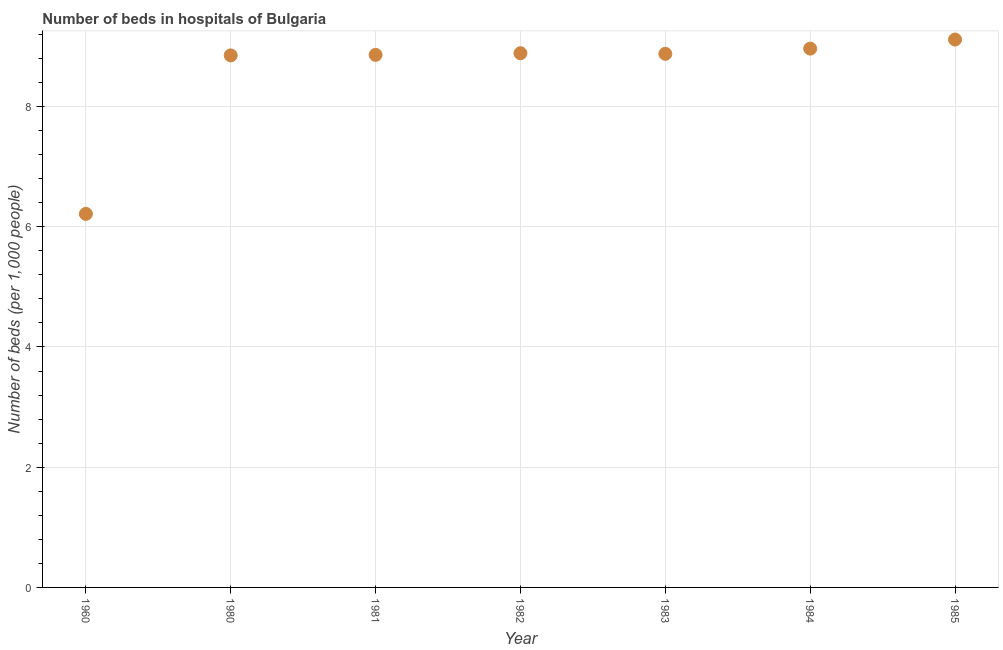What is the number of hospital beds in 1982?
Offer a terse response. 8.89. Across all years, what is the maximum number of hospital beds?
Give a very brief answer. 9.11. Across all years, what is the minimum number of hospital beds?
Offer a terse response. 6.21. What is the sum of the number of hospital beds?
Provide a short and direct response. 59.76. What is the difference between the number of hospital beds in 1983 and 1985?
Your answer should be compact. -0.24. What is the average number of hospital beds per year?
Your answer should be compact. 8.54. What is the median number of hospital beds?
Keep it short and to the point. 8.88. Do a majority of the years between 1984 and 1981 (inclusive) have number of hospital beds greater than 6 %?
Provide a short and direct response. Yes. What is the ratio of the number of hospital beds in 1982 to that in 1985?
Ensure brevity in your answer.  0.98. Is the number of hospital beds in 1960 less than that in 1983?
Your response must be concise. Yes. What is the difference between the highest and the second highest number of hospital beds?
Provide a succinct answer. 0.15. What is the difference between the highest and the lowest number of hospital beds?
Ensure brevity in your answer.  2.9. In how many years, is the number of hospital beds greater than the average number of hospital beds taken over all years?
Your answer should be very brief. 6. Does the number of hospital beds monotonically increase over the years?
Provide a succinct answer. No. How many dotlines are there?
Offer a terse response. 1. How many years are there in the graph?
Your answer should be compact. 7. Does the graph contain any zero values?
Provide a short and direct response. No. Does the graph contain grids?
Keep it short and to the point. Yes. What is the title of the graph?
Provide a short and direct response. Number of beds in hospitals of Bulgaria. What is the label or title of the Y-axis?
Offer a terse response. Number of beds (per 1,0 people). What is the Number of beds (per 1,000 people) in 1960?
Your answer should be compact. 6.21. What is the Number of beds (per 1,000 people) in 1980?
Provide a short and direct response. 8.85. What is the Number of beds (per 1,000 people) in 1981?
Offer a very short reply. 8.86. What is the Number of beds (per 1,000 people) in 1982?
Give a very brief answer. 8.89. What is the Number of beds (per 1,000 people) in 1983?
Make the answer very short. 8.88. What is the Number of beds (per 1,000 people) in 1984?
Provide a short and direct response. 8.96. What is the Number of beds (per 1,000 people) in 1985?
Provide a succinct answer. 9.11. What is the difference between the Number of beds (per 1,000 people) in 1960 and 1980?
Your answer should be compact. -2.64. What is the difference between the Number of beds (per 1,000 people) in 1960 and 1981?
Keep it short and to the point. -2.65. What is the difference between the Number of beds (per 1,000 people) in 1960 and 1982?
Make the answer very short. -2.67. What is the difference between the Number of beds (per 1,000 people) in 1960 and 1983?
Your answer should be compact. -2.66. What is the difference between the Number of beds (per 1,000 people) in 1960 and 1984?
Your answer should be compact. -2.75. What is the difference between the Number of beds (per 1,000 people) in 1960 and 1985?
Offer a terse response. -2.9. What is the difference between the Number of beds (per 1,000 people) in 1980 and 1981?
Keep it short and to the point. -0.01. What is the difference between the Number of beds (per 1,000 people) in 1980 and 1982?
Your answer should be very brief. -0.04. What is the difference between the Number of beds (per 1,000 people) in 1980 and 1983?
Give a very brief answer. -0.03. What is the difference between the Number of beds (per 1,000 people) in 1980 and 1984?
Provide a short and direct response. -0.11. What is the difference between the Number of beds (per 1,000 people) in 1980 and 1985?
Your response must be concise. -0.26. What is the difference between the Number of beds (per 1,000 people) in 1981 and 1982?
Your answer should be very brief. -0.03. What is the difference between the Number of beds (per 1,000 people) in 1981 and 1983?
Provide a succinct answer. -0.02. What is the difference between the Number of beds (per 1,000 people) in 1981 and 1984?
Give a very brief answer. -0.1. What is the difference between the Number of beds (per 1,000 people) in 1981 and 1985?
Your answer should be very brief. -0.26. What is the difference between the Number of beds (per 1,000 people) in 1982 and 1983?
Your answer should be very brief. 0.01. What is the difference between the Number of beds (per 1,000 people) in 1982 and 1984?
Give a very brief answer. -0.08. What is the difference between the Number of beds (per 1,000 people) in 1982 and 1985?
Keep it short and to the point. -0.23. What is the difference between the Number of beds (per 1,000 people) in 1983 and 1984?
Ensure brevity in your answer.  -0.09. What is the difference between the Number of beds (per 1,000 people) in 1983 and 1985?
Provide a succinct answer. -0.24. What is the difference between the Number of beds (per 1,000 people) in 1984 and 1985?
Offer a very short reply. -0.15. What is the ratio of the Number of beds (per 1,000 people) in 1960 to that in 1980?
Ensure brevity in your answer.  0.7. What is the ratio of the Number of beds (per 1,000 people) in 1960 to that in 1981?
Offer a terse response. 0.7. What is the ratio of the Number of beds (per 1,000 people) in 1960 to that in 1982?
Provide a short and direct response. 0.7. What is the ratio of the Number of beds (per 1,000 people) in 1960 to that in 1983?
Make the answer very short. 0.7. What is the ratio of the Number of beds (per 1,000 people) in 1960 to that in 1984?
Offer a very short reply. 0.69. What is the ratio of the Number of beds (per 1,000 people) in 1960 to that in 1985?
Provide a succinct answer. 0.68. What is the ratio of the Number of beds (per 1,000 people) in 1980 to that in 1981?
Your answer should be very brief. 1. What is the ratio of the Number of beds (per 1,000 people) in 1980 to that in 1982?
Provide a succinct answer. 1. What is the ratio of the Number of beds (per 1,000 people) in 1980 to that in 1983?
Your answer should be compact. 1. What is the ratio of the Number of beds (per 1,000 people) in 1980 to that in 1984?
Make the answer very short. 0.99. What is the ratio of the Number of beds (per 1,000 people) in 1980 to that in 1985?
Your response must be concise. 0.97. What is the ratio of the Number of beds (per 1,000 people) in 1981 to that in 1982?
Make the answer very short. 1. What is the ratio of the Number of beds (per 1,000 people) in 1981 to that in 1983?
Provide a succinct answer. 1. What is the ratio of the Number of beds (per 1,000 people) in 1981 to that in 1985?
Your answer should be very brief. 0.97. What is the ratio of the Number of beds (per 1,000 people) in 1982 to that in 1983?
Your answer should be very brief. 1. What is the ratio of the Number of beds (per 1,000 people) in 1983 to that in 1984?
Provide a short and direct response. 0.99. What is the ratio of the Number of beds (per 1,000 people) in 1983 to that in 1985?
Keep it short and to the point. 0.97. What is the ratio of the Number of beds (per 1,000 people) in 1984 to that in 1985?
Provide a succinct answer. 0.98. 